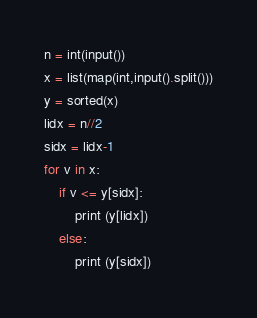<code> <loc_0><loc_0><loc_500><loc_500><_Python_>n = int(input())
x = list(map(int,input().split()))
y = sorted(x)
lidx = n//2
sidx = lidx-1
for v in x:
    if v <= y[sidx]:
        print (y[lidx])
    else:
        print (y[sidx])
</code> 